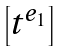<formula> <loc_0><loc_0><loc_500><loc_500>\begin{bmatrix} t ^ { e _ { 1 } } \end{bmatrix}</formula> 